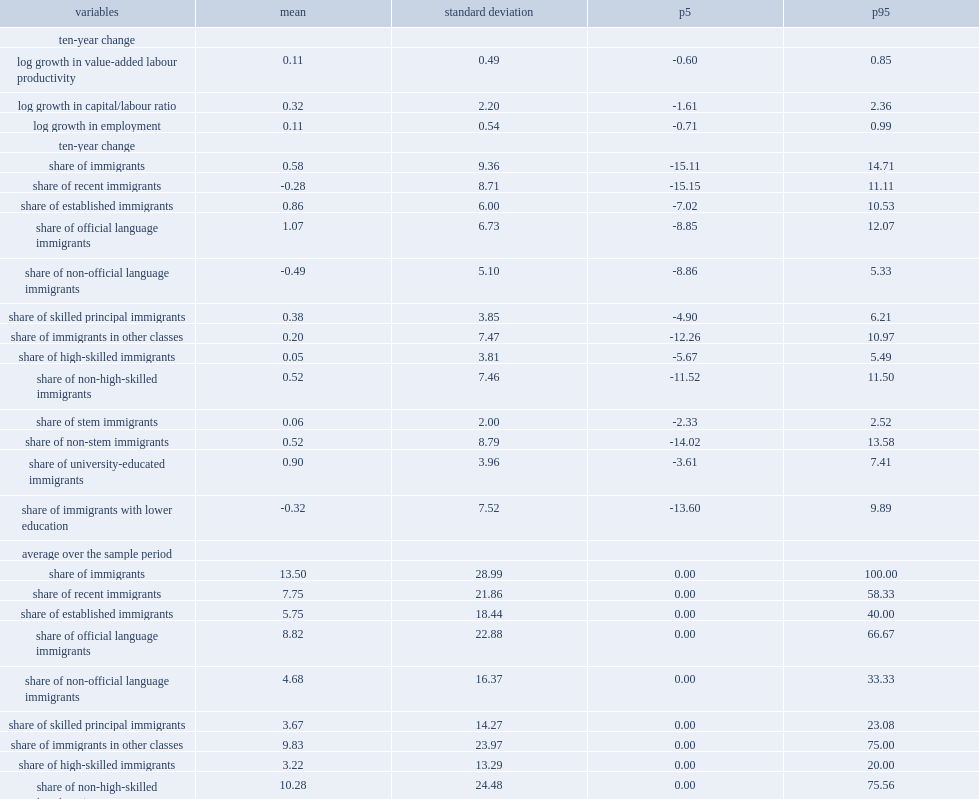What is the percentage of share of immigrant employment in the sample? 13.5. Compared with the share of immigrant with relatively low skill level (immigrants in classes other than economic classes) and the share of immigrants with relatively high skill level,which one was much higher? Share of immigrants in other classes. Compared with the share of immigrant with relatively low skill level (immigrants with relatively high skill level) and the share of immigrants with relatively high skill level,which one was much higher? Share of non-high-skilled immigrants. Compared with the share of immigrant with relatively low skill level (non-stem immigrants) and the share of immigrants with relatively high skill level,which one was much higher? Share of non-stem immigrants. Compared with the share of immigrant with relatively low skill level (immigrants with lower education) and the share of immigrants with relatively high skill level,which one was much higher? Share of immigrants with lower education. Compared with the share of recent immigrants (who were in canada with 10 years or less) and the share of established immigrants, which one was much higher? Share of recent immigrants. What is the percentage of the share of recent immigrants (who were in canada with 10 years or less) ? 7.75. What is the percentage of the share of established immigrants ? 5.75. Over a ten-year period, what is the percentage of the share of immigrant employment increased in an average firm? 0.58. What is the smallest change of average over the sample period? Share of stem immigrants. 